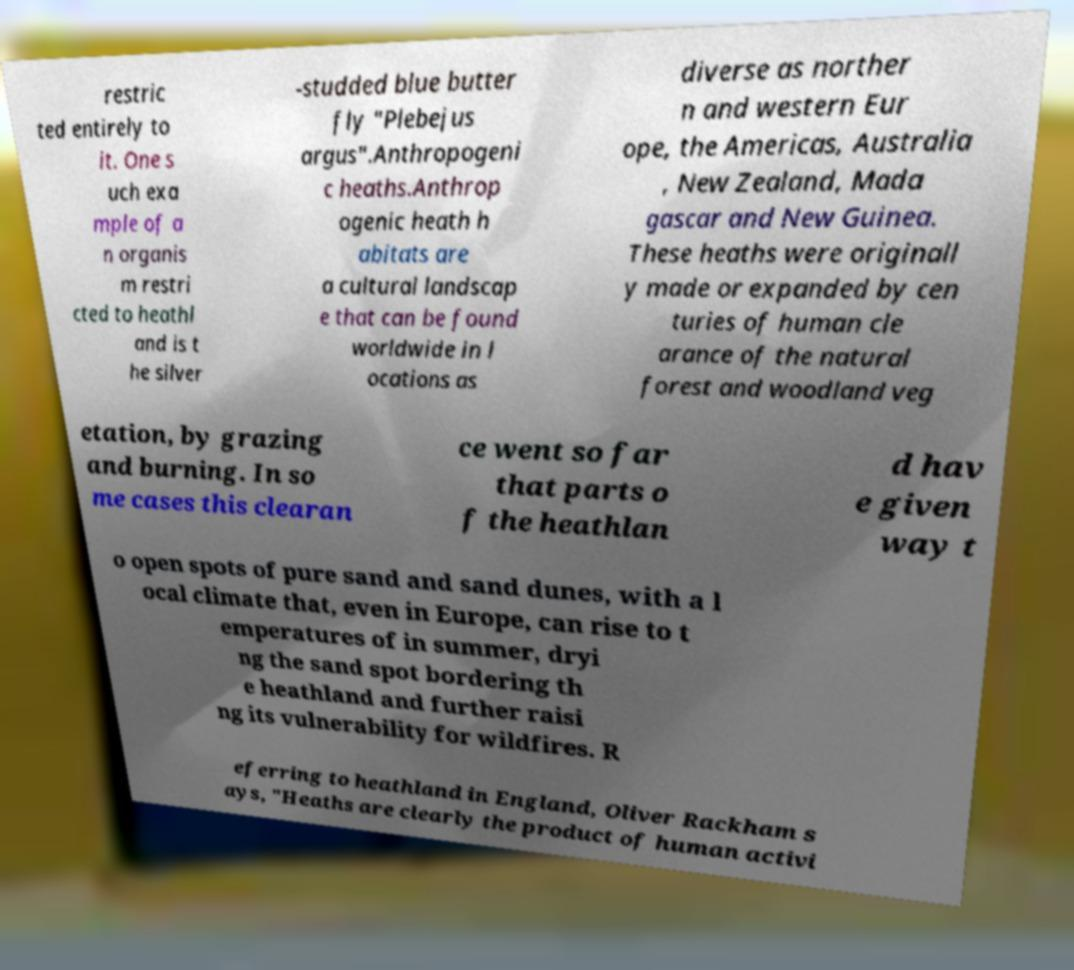I need the written content from this picture converted into text. Can you do that? restric ted entirely to it. One s uch exa mple of a n organis m restri cted to heathl and is t he silver -studded blue butter fly "Plebejus argus".Anthropogeni c heaths.Anthrop ogenic heath h abitats are a cultural landscap e that can be found worldwide in l ocations as diverse as norther n and western Eur ope, the Americas, Australia , New Zealand, Mada gascar and New Guinea. These heaths were originall y made or expanded by cen turies of human cle arance of the natural forest and woodland veg etation, by grazing and burning. In so me cases this clearan ce went so far that parts o f the heathlan d hav e given way t o open spots of pure sand and sand dunes, with a l ocal climate that, even in Europe, can rise to t emperatures of in summer, dryi ng the sand spot bordering th e heathland and further raisi ng its vulnerability for wildfires. R eferring to heathland in England, Oliver Rackham s ays, "Heaths are clearly the product of human activi 